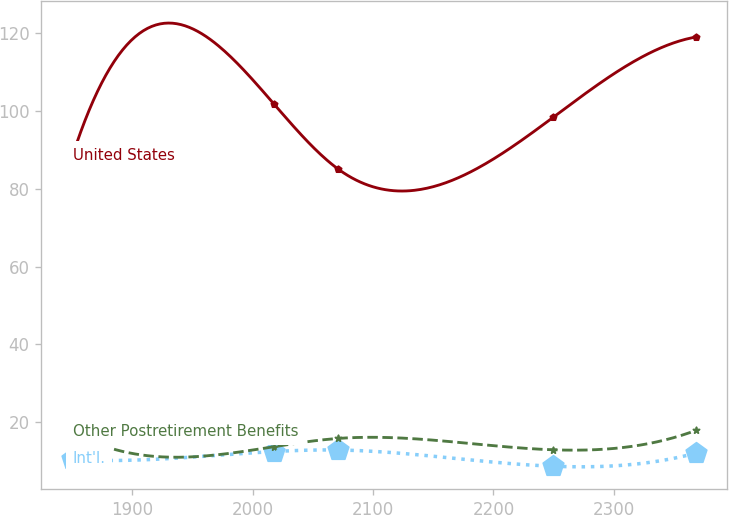Convert chart. <chart><loc_0><loc_0><loc_500><loc_500><line_chart><ecel><fcel>Int'l.<fcel>United States<fcel>Other Postretirement Benefits<nl><fcel>1850.39<fcel>10.38<fcel>88.45<fcel>17.4<nl><fcel>2017.96<fcel>12.42<fcel>101.75<fcel>13.68<nl><fcel>2071.2<fcel>12.81<fcel>85.05<fcel>15.79<nl><fcel>2249.47<fcel>8.64<fcel>98.35<fcel>12.87<nl><fcel>2368.51<fcel>12.03<fcel>119.06<fcel>17.88<nl></chart> 